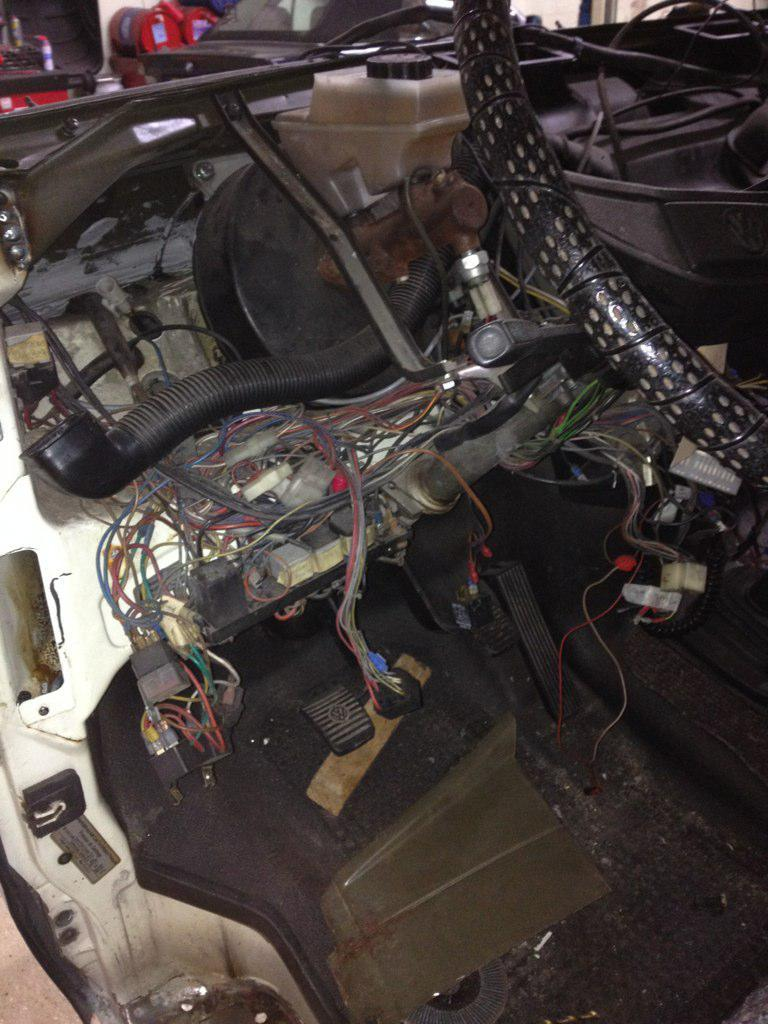What type of object is featured in the image? There is an engine part and a steering wheel in the image. Can you describe the engine part in the image? Unfortunately, the specific details of the engine part cannot be determined from the image alone. What is the purpose of the steering wheel in the image? The steering wheel is likely used for controlling the direction of a vehicle or machine. How does the porter help people cross the wave in the image? There is no porter, wave, or any indication of people crossing in the image. 